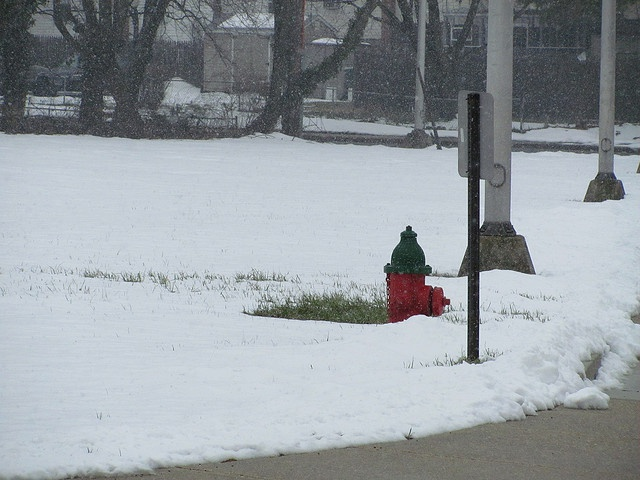Describe the objects in this image and their specific colors. I can see a fire hydrant in black, maroon, gray, and lightgray tones in this image. 